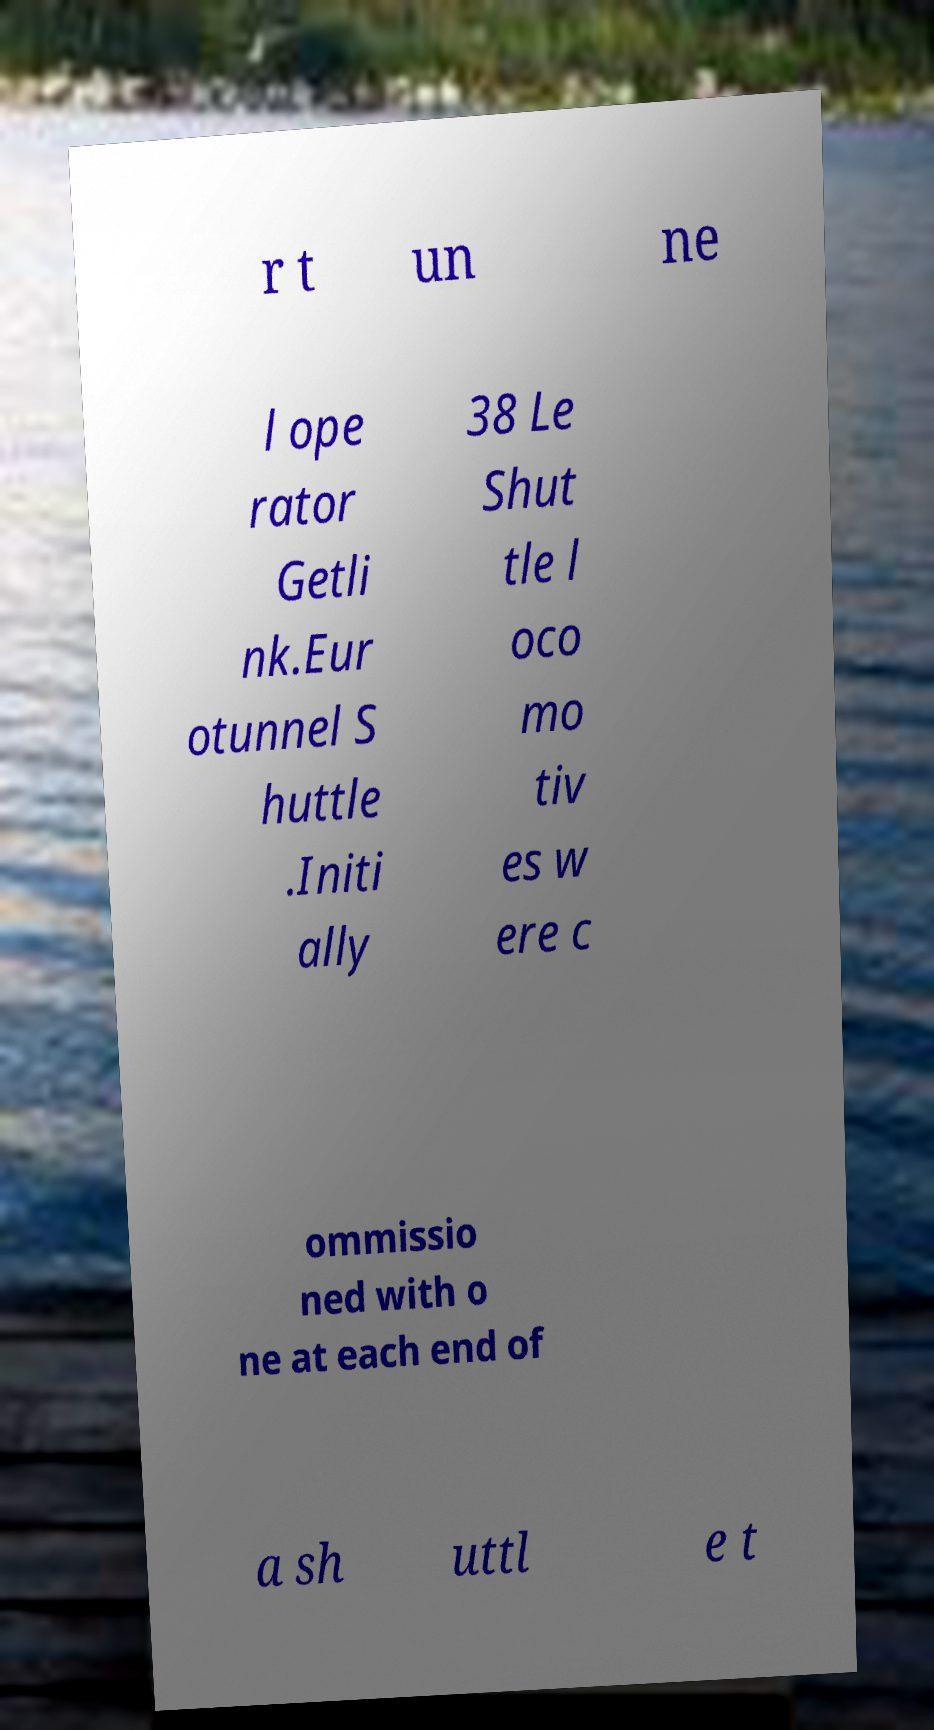For documentation purposes, I need the text within this image transcribed. Could you provide that? r t un ne l ope rator Getli nk.Eur otunnel S huttle .Initi ally 38 Le Shut tle l oco mo tiv es w ere c ommissio ned with o ne at each end of a sh uttl e t 